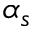<formula> <loc_0><loc_0><loc_500><loc_500>\alpha _ { s }</formula> 